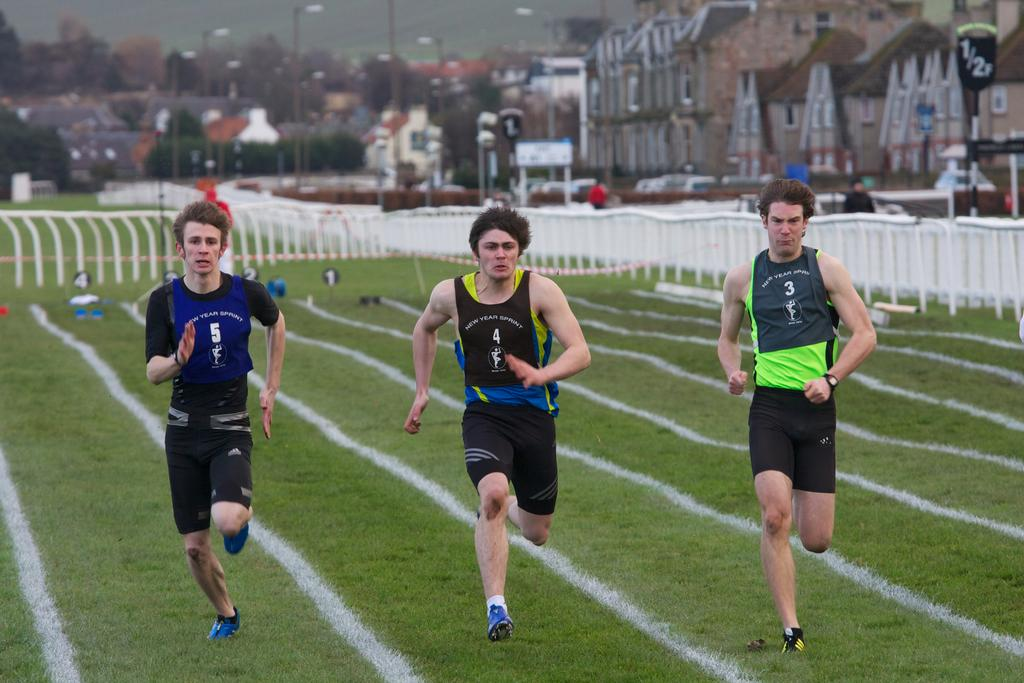<image>
Write a terse but informative summary of the picture. Three men are running a race and the jersey of the man in the center is numbered 4. 